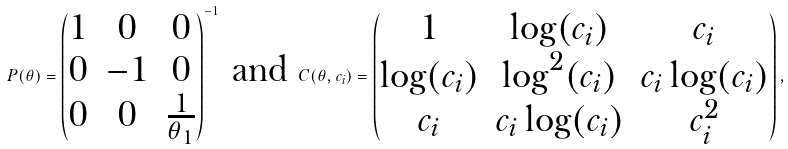Convert formula to latex. <formula><loc_0><loc_0><loc_500><loc_500>P ( \theta ) = \begin{pmatrix} 1 & 0 & 0 \\ 0 & - 1 & 0 \\ 0 & 0 & \frac { 1 } { \theta _ { 1 } } \end{pmatrix} ^ { - 1 } \text { and } C ( \theta , c _ { i } ) = \begin{pmatrix} 1 & \log ( c _ { i } ) & c _ { i } \\ \log ( c _ { i } ) & \log ^ { 2 } ( c _ { i } ) & c _ { i } \log ( c _ { i } ) \\ c _ { i } & c _ { i } \log ( c _ { i } ) & c _ { i } ^ { 2 } \end{pmatrix} ,</formula> 